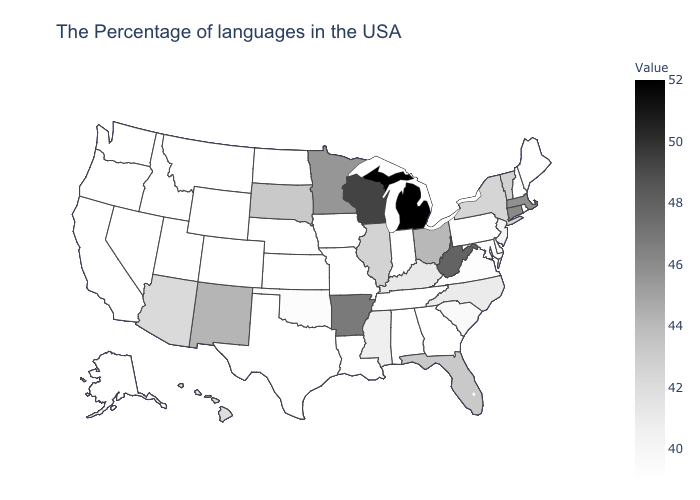Does Maine have the lowest value in the Northeast?
Quick response, please. Yes. Among the states that border Missouri , which have the lowest value?
Be succinct. Tennessee, Iowa, Kansas, Nebraska. Does Hawaii have the lowest value in the West?
Write a very short answer. No. Does Nebraska have a higher value than Massachusetts?
Short answer required. No. 